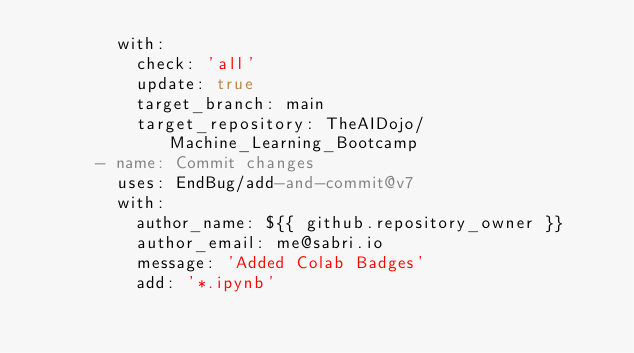<code> <loc_0><loc_0><loc_500><loc_500><_YAML_>        with:
          check: 'all'
          update: true
          target_branch: main
          target_repository: TheAIDojo/Machine_Learning_Bootcamp
      - name: Commit changes
        uses: EndBug/add-and-commit@v7
        with:
          author_name: ${{ github.repository_owner }}
          author_email: me@sabri.io
          message: 'Added Colab Badges'
          add: '*.ipynb'
</code> 